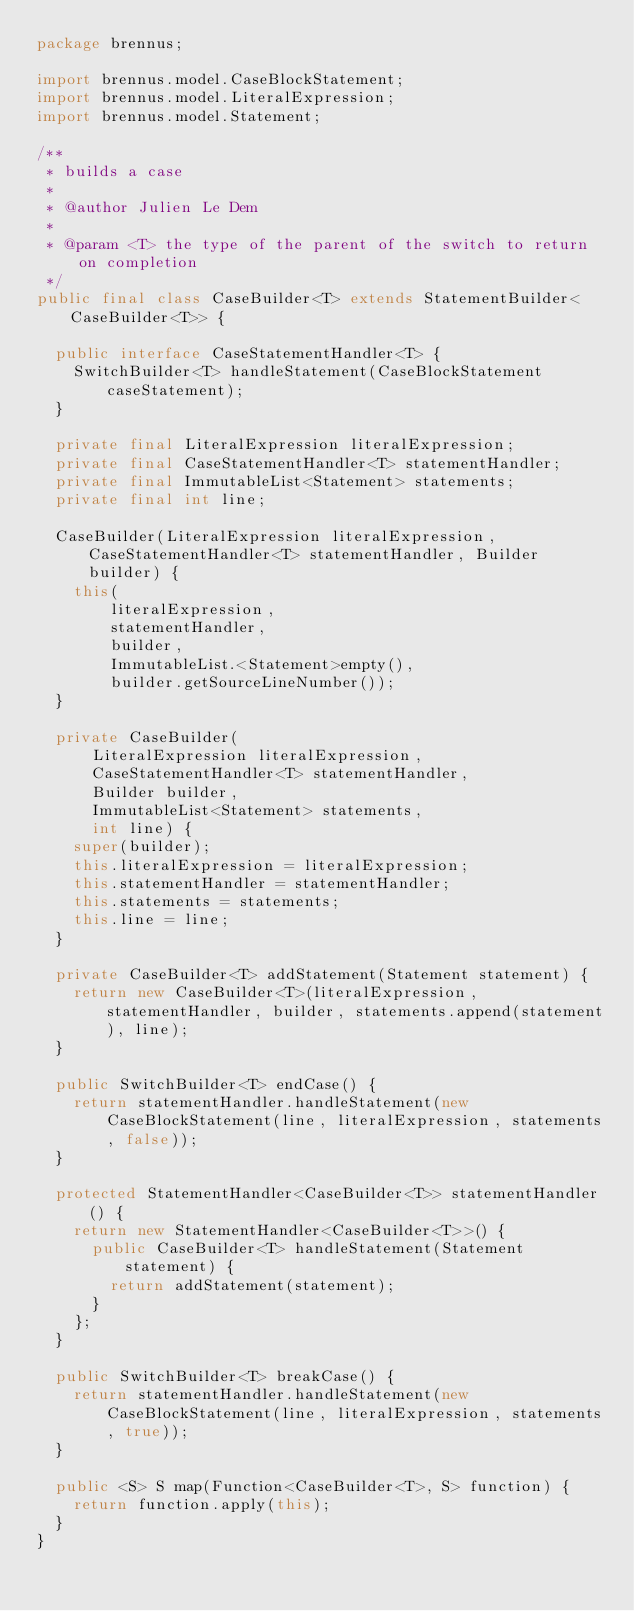<code> <loc_0><loc_0><loc_500><loc_500><_Java_>package brennus;

import brennus.model.CaseBlockStatement;
import brennus.model.LiteralExpression;
import brennus.model.Statement;

/**
 * builds a case
 *
 * @author Julien Le Dem
 *
 * @param <T> the type of the parent of the switch to return on completion
 */
public final class CaseBuilder<T> extends StatementBuilder<CaseBuilder<T>> {

  public interface CaseStatementHandler<T> {
    SwitchBuilder<T> handleStatement(CaseBlockStatement caseStatement);
  }

  private final LiteralExpression literalExpression;
  private final CaseStatementHandler<T> statementHandler;
  private final ImmutableList<Statement> statements;
  private final int line;

  CaseBuilder(LiteralExpression literalExpression, CaseStatementHandler<T> statementHandler, Builder builder) {
    this(
        literalExpression,
        statementHandler,
        builder,
        ImmutableList.<Statement>empty(),
        builder.getSourceLineNumber());
  }

  private CaseBuilder(
      LiteralExpression literalExpression,
      CaseStatementHandler<T> statementHandler,
      Builder builder,
      ImmutableList<Statement> statements,
      int line) {
    super(builder);
    this.literalExpression = literalExpression;
    this.statementHandler = statementHandler;
    this.statements = statements;
    this.line = line;
  }

  private CaseBuilder<T> addStatement(Statement statement) {
    return new CaseBuilder<T>(literalExpression, statementHandler, builder, statements.append(statement), line);
  }

  public SwitchBuilder<T> endCase() {
    return statementHandler.handleStatement(new CaseBlockStatement(line, literalExpression, statements, false));
  }

  protected StatementHandler<CaseBuilder<T>> statementHandler() {
    return new StatementHandler<CaseBuilder<T>>() {
      public CaseBuilder<T> handleStatement(Statement statement) {
        return addStatement(statement);
      }
    };
  }

  public SwitchBuilder<T> breakCase() {
    return statementHandler.handleStatement(new CaseBlockStatement(line, literalExpression, statements, true));
  }

  public <S> S map(Function<CaseBuilder<T>, S> function) {
    return function.apply(this);
  }
}
</code> 